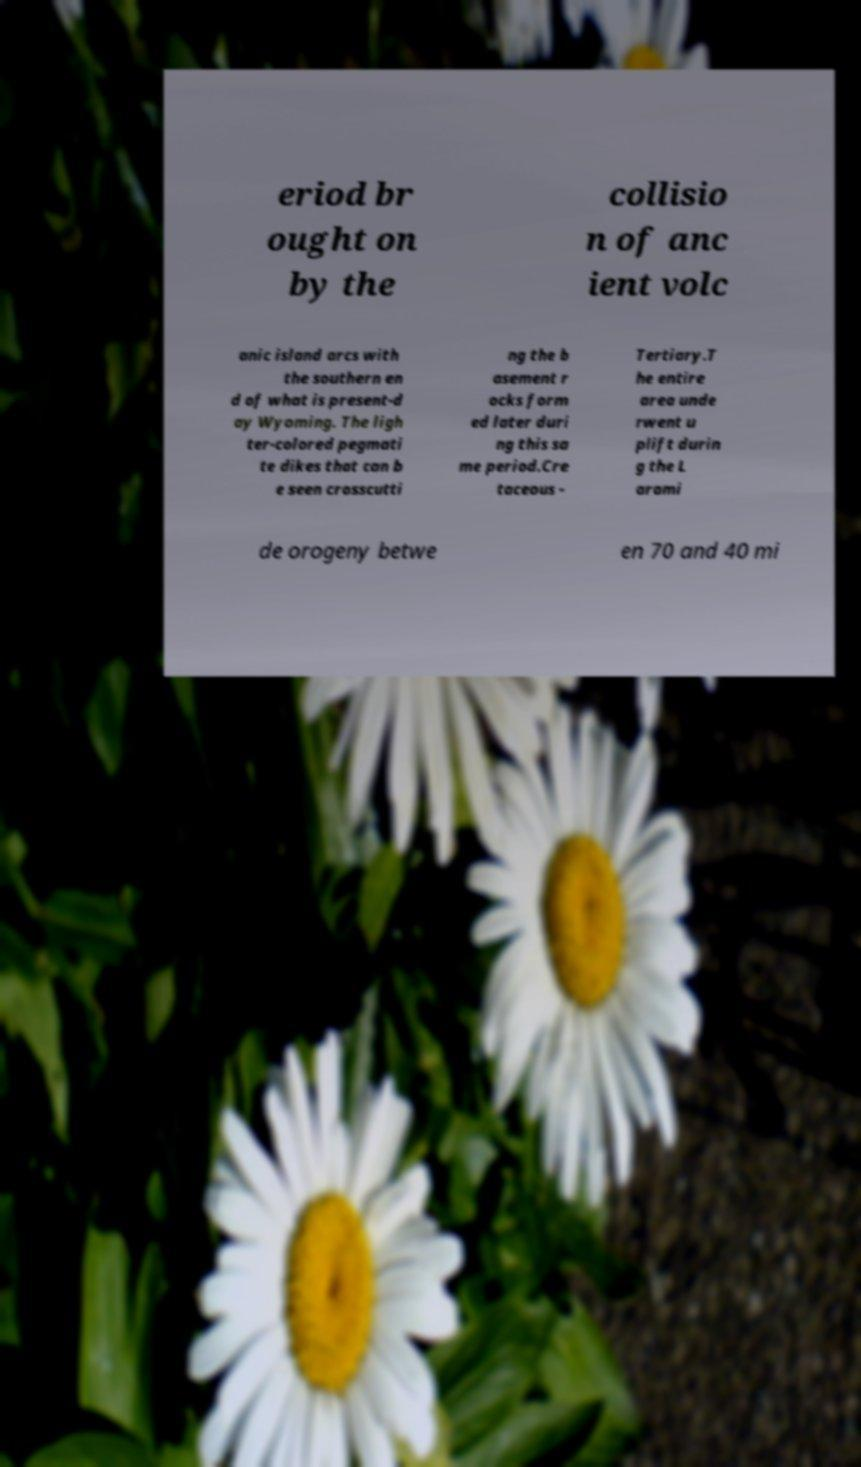What messages or text are displayed in this image? I need them in a readable, typed format. eriod br ought on by the collisio n of anc ient volc anic island arcs with the southern en d of what is present-d ay Wyoming. The ligh ter-colored pegmati te dikes that can b e seen crosscutti ng the b asement r ocks form ed later duri ng this sa me period.Cre taceous - Tertiary.T he entire area unde rwent u plift durin g the L arami de orogeny betwe en 70 and 40 mi 